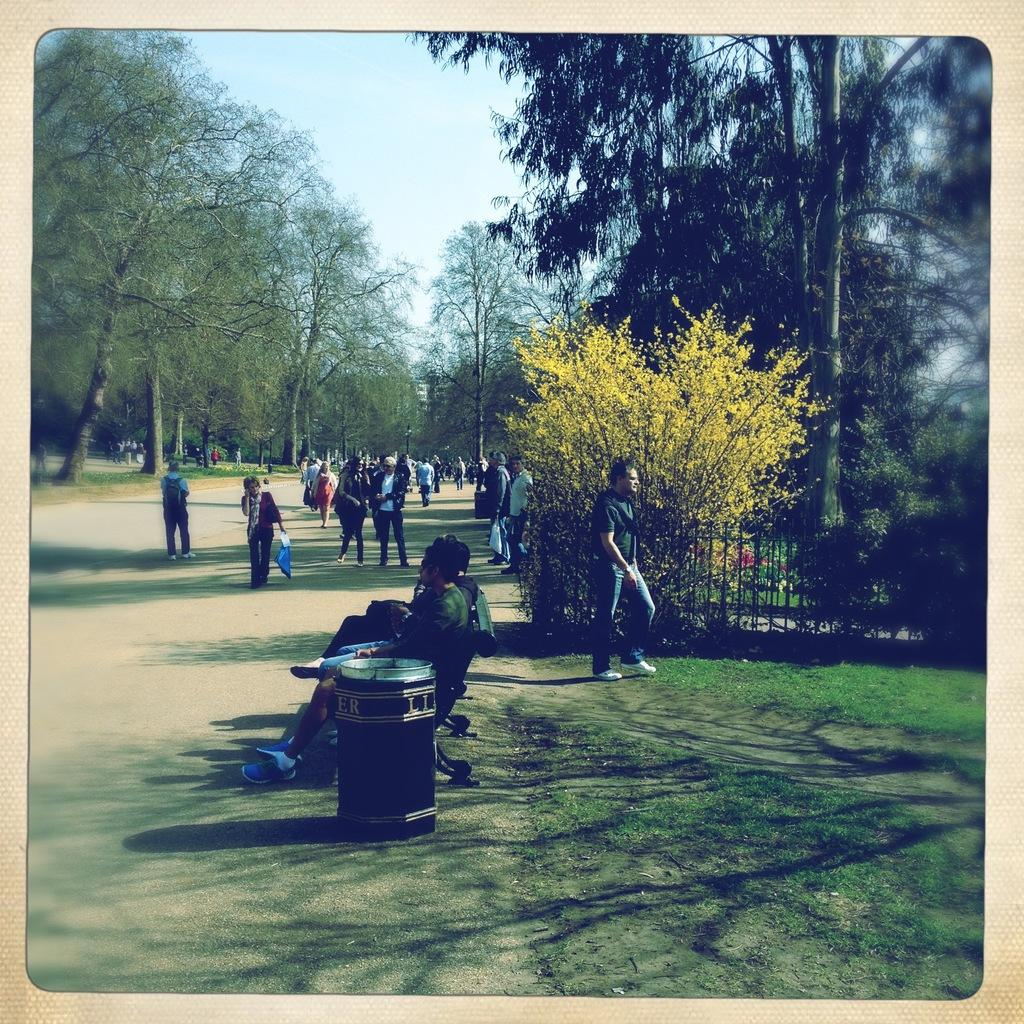What is the main subject of the image? The main subject of the image is a photograph. What can be seen in the photograph? The photograph contains people standing on the road, people sitting on a bench, bins, grills, trees, and the sky. What type of outdoor furniture is present in the photograph? There is a bench in the photograph. What type of vegetation is present in the photograph? There are trees in the photograph. What type of bread can be seen on top of the grills in the image? There is no bread visible on top of the grills in the image. How many boys are sitting on the bench in the image? There is no boy present in the image; only people are visible in the photograph. 